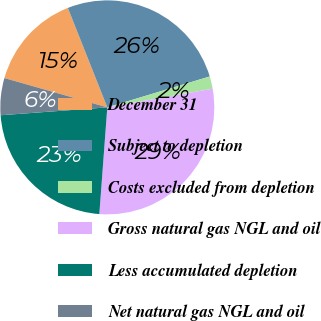Convert chart. <chart><loc_0><loc_0><loc_500><loc_500><pie_chart><fcel>December 31<fcel>Subject to depletion<fcel>Costs excluded from depletion<fcel>Gross natural gas NGL and oil<fcel>Less accumulated depletion<fcel>Net natural gas NGL and oil<nl><fcel>14.57%<fcel>26.35%<fcel>1.87%<fcel>28.98%<fcel>22.64%<fcel>5.59%<nl></chart> 